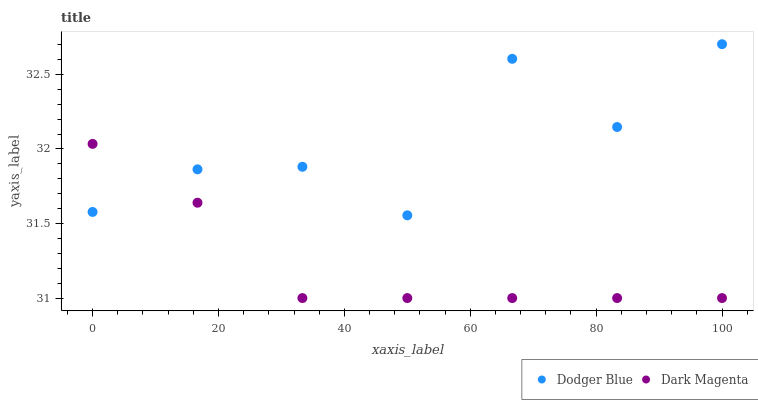Does Dark Magenta have the minimum area under the curve?
Answer yes or no. Yes. Does Dodger Blue have the maximum area under the curve?
Answer yes or no. Yes. Does Dark Magenta have the maximum area under the curve?
Answer yes or no. No. Is Dark Magenta the smoothest?
Answer yes or no. Yes. Is Dodger Blue the roughest?
Answer yes or no. Yes. Is Dark Magenta the roughest?
Answer yes or no. No. Does Dark Magenta have the lowest value?
Answer yes or no. Yes. Does Dodger Blue have the highest value?
Answer yes or no. Yes. Does Dark Magenta have the highest value?
Answer yes or no. No. Does Dodger Blue intersect Dark Magenta?
Answer yes or no. Yes. Is Dodger Blue less than Dark Magenta?
Answer yes or no. No. Is Dodger Blue greater than Dark Magenta?
Answer yes or no. No. 